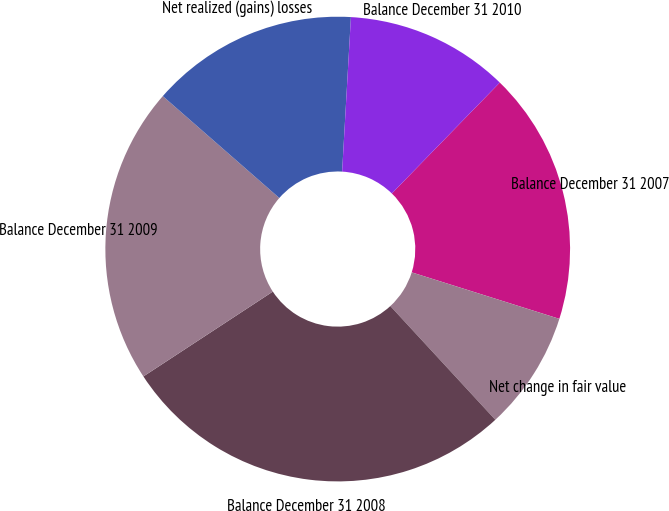Convert chart. <chart><loc_0><loc_0><loc_500><loc_500><pie_chart><fcel>Balance December 31 2007<fcel>Net change in fair value<fcel>Balance December 31 2008<fcel>Balance December 31 2009<fcel>Net realized (gains) losses<fcel>Balance December 31 2010<nl><fcel>17.57%<fcel>8.28%<fcel>27.63%<fcel>20.67%<fcel>14.47%<fcel>11.38%<nl></chart> 